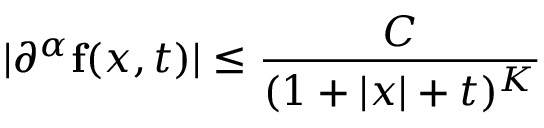<formula> <loc_0><loc_0><loc_500><loc_500>| \partial ^ { \alpha } f ( x , t ) | \leq { \frac { C } { ( 1 + | x | + t ) ^ { K } } }</formula> 